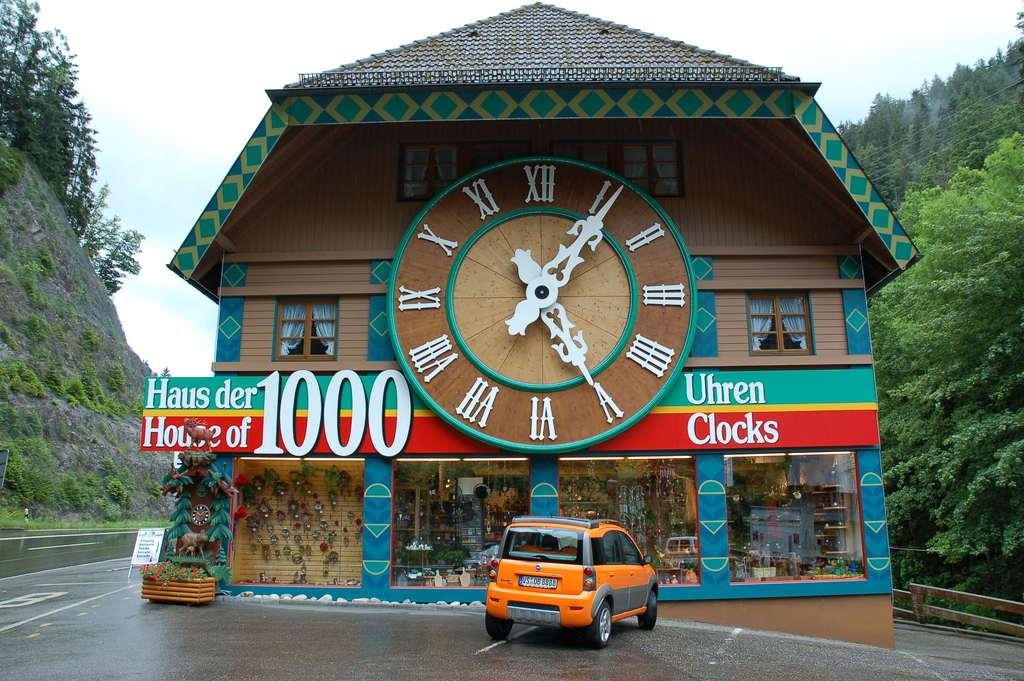<image>
Offer a succinct explanation of the picture presented. A brightly coloured building with a large clock has the word clocks on it 